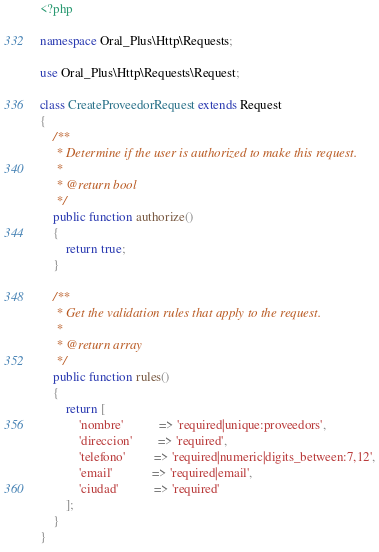<code> <loc_0><loc_0><loc_500><loc_500><_PHP_><?php

namespace Oral_Plus\Http\Requests;

use Oral_Plus\Http\Requests\Request;

class CreateProveedorRequest extends Request
{
    /**
     * Determine if the user is authorized to make this request.
     *
     * @return bool
     */
    public function authorize()
    {
        return true;
    }

    /**
     * Get the validation rules that apply to the request.
     *
     * @return array
     */
    public function rules()
    {
        return [
            'nombre'           => 'required|unique:proveedors',
            'direccion'        => 'required',
            'telefono'         => 'required|numeric|digits_between:7,12',
            'email'            => 'required|email',
            'ciudad'           => 'required'
        ];
    }
}
</code> 